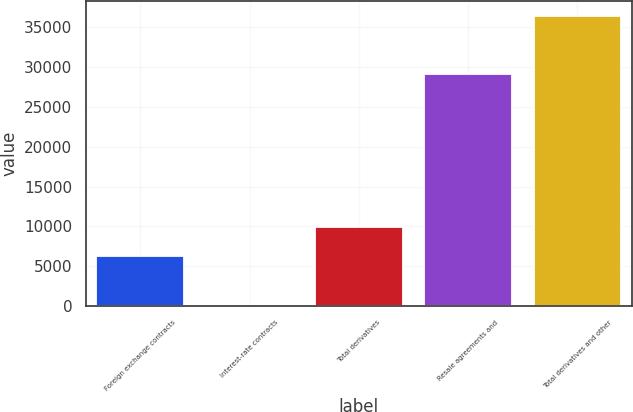Convert chart to OTSL. <chart><loc_0><loc_0><loc_500><loc_500><bar_chart><fcel>Foreign exchange contracts<fcel>Interest-rate contracts<fcel>Total derivatives<fcel>Resale agreements and<fcel>Total derivatives and other<nl><fcel>6275<fcel>21<fcel>9916.6<fcel>29157<fcel>36437<nl></chart> 